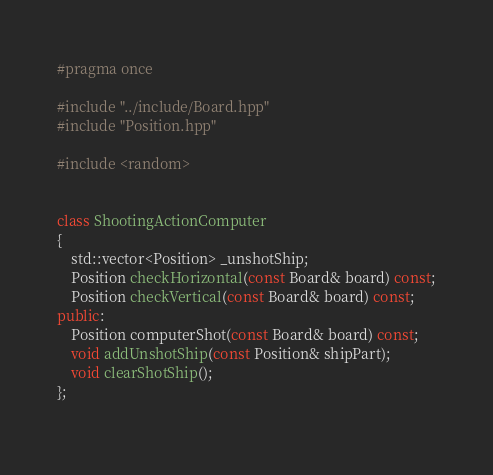Convert code to text. <code><loc_0><loc_0><loc_500><loc_500><_C++_>#pragma once

#include "../include/Board.hpp"
#include "Position.hpp"

#include <random>

  
class ShootingActionComputer
{
    std::vector<Position> _unshotShip;
    Position checkHorizontal(const Board& board) const;
    Position checkVertical(const Board& board) const;
public:
    Position computerShot(const Board& board) const;
    void addUnshotShip(const Position& shipPart);
    void clearShotShip();
};
    </code> 